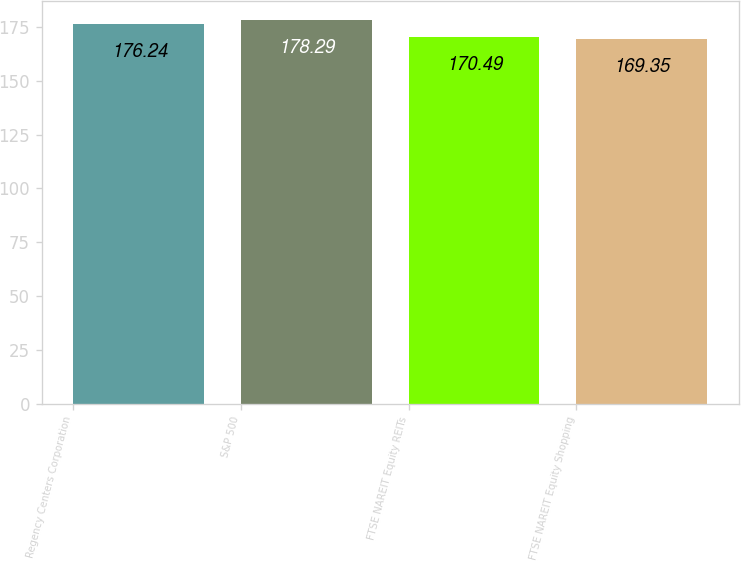Convert chart to OTSL. <chart><loc_0><loc_0><loc_500><loc_500><bar_chart><fcel>Regency Centers Corporation<fcel>S&P 500<fcel>FTSE NAREIT Equity REITs<fcel>FTSE NAREIT Equity Shopping<nl><fcel>176.24<fcel>178.29<fcel>170.49<fcel>169.35<nl></chart> 